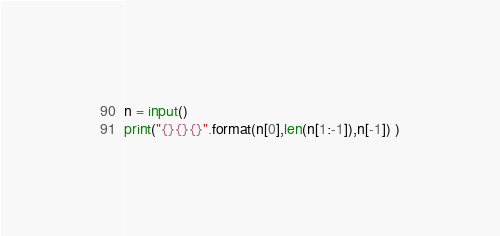<code> <loc_0><loc_0><loc_500><loc_500><_Python_>n = input()
print("{}{}{}".format(n[0],len(n[1:-1]),n[-1]) )</code> 